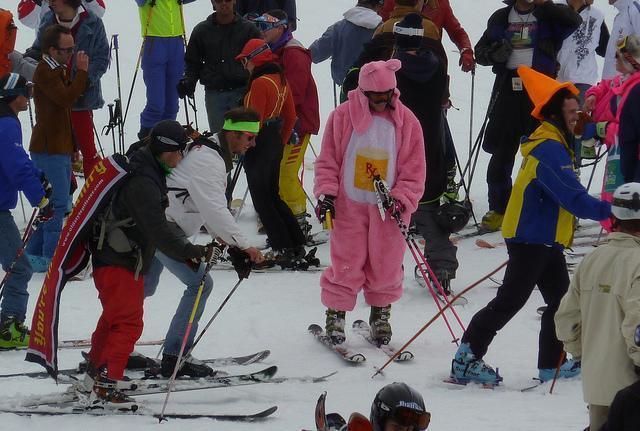How many people are in the photo?
Give a very brief answer. 13. How many ski can be seen?
Give a very brief answer. 1. How many elephants are pictured in this photo?
Give a very brief answer. 0. 